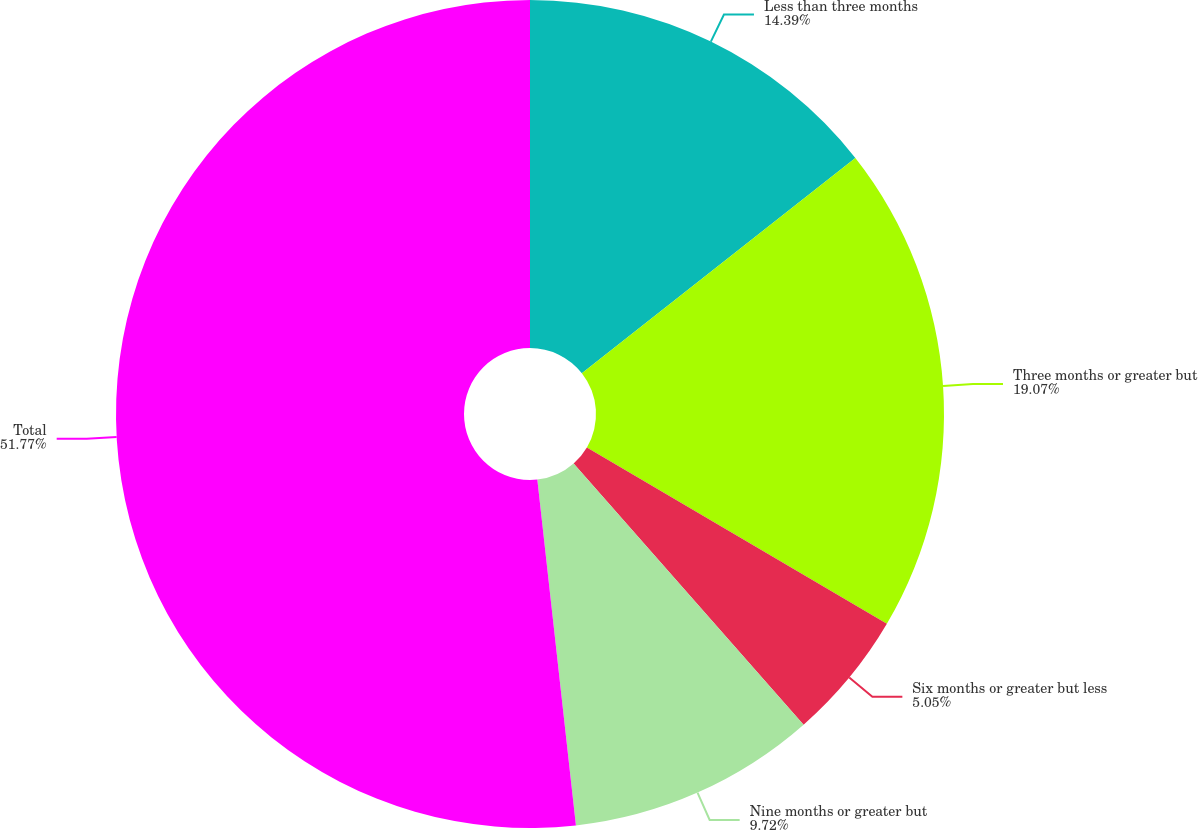<chart> <loc_0><loc_0><loc_500><loc_500><pie_chart><fcel>Less than three months<fcel>Three months or greater but<fcel>Six months or greater but less<fcel>Nine months or greater but<fcel>Total<nl><fcel>14.39%<fcel>19.07%<fcel>5.05%<fcel>9.72%<fcel>51.77%<nl></chart> 